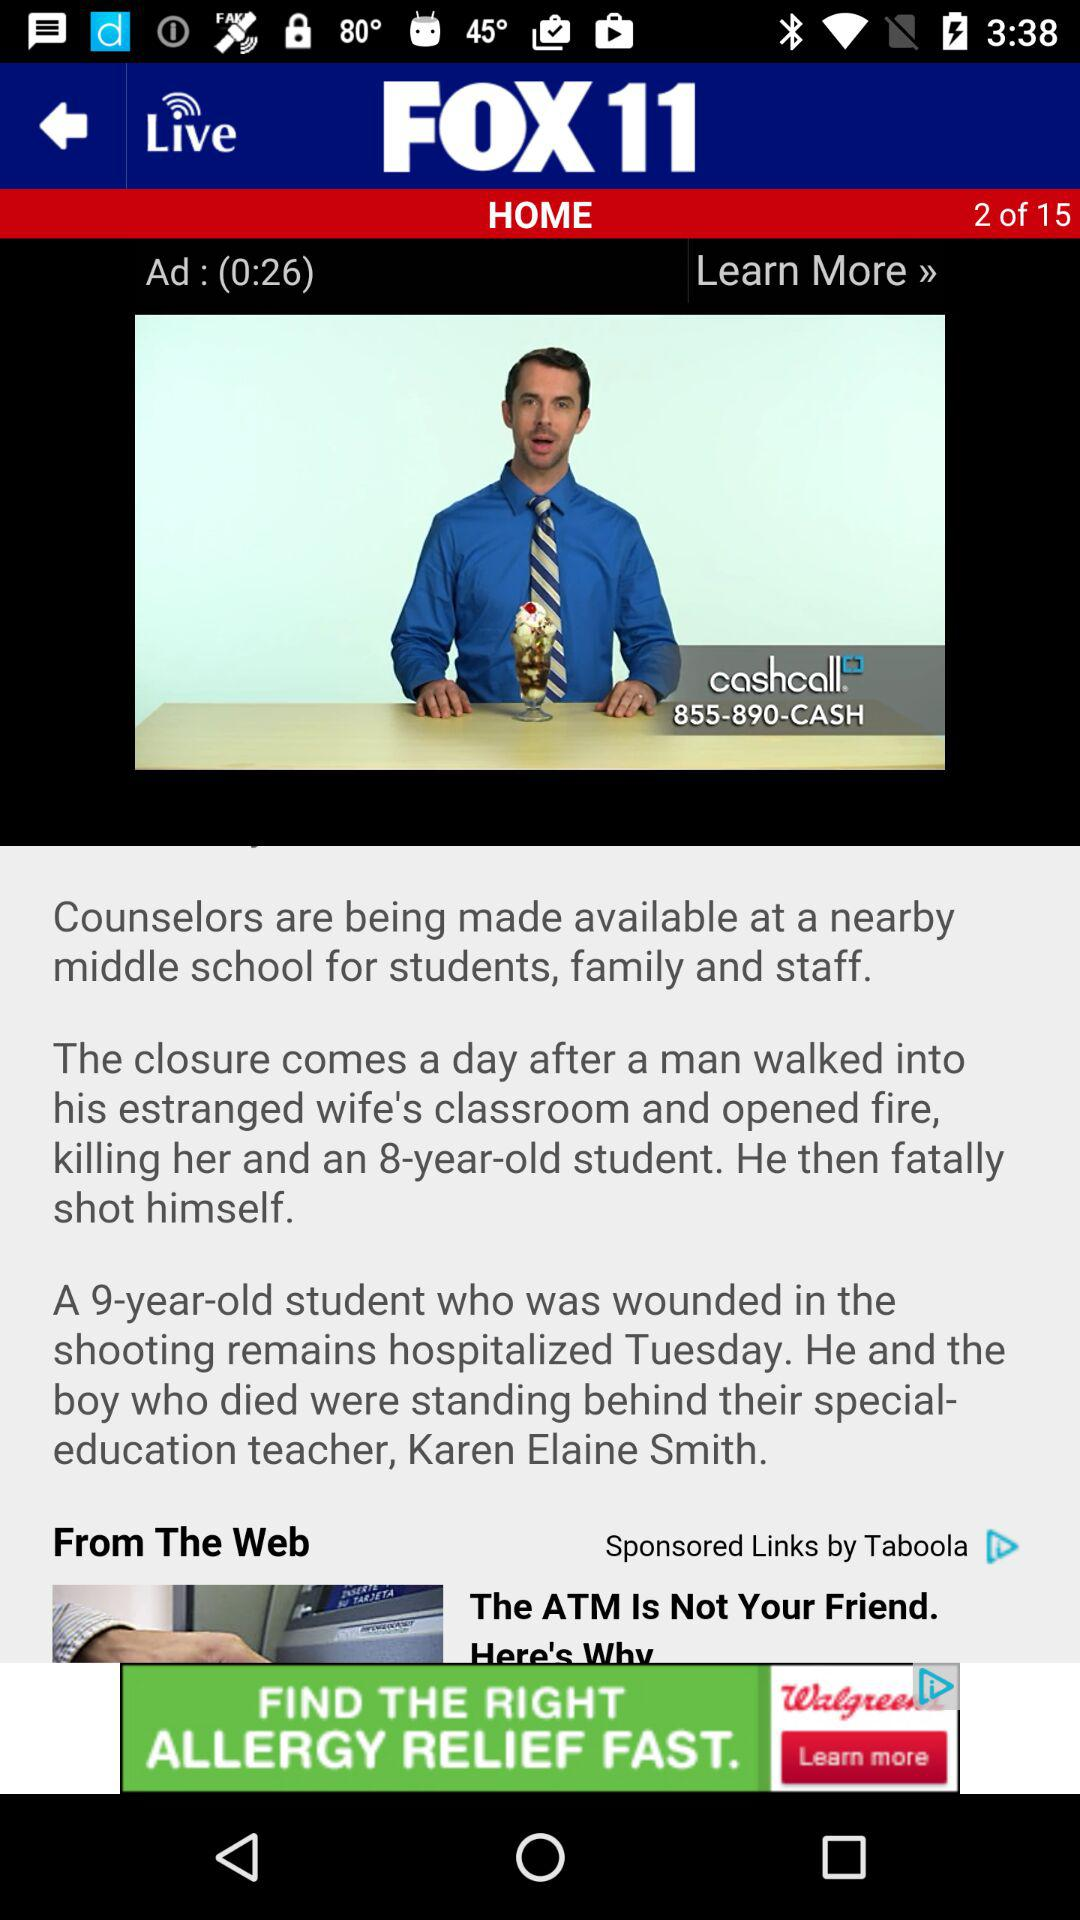When was the story published?
When the provided information is insufficient, respond with <no answer>. <no answer> 